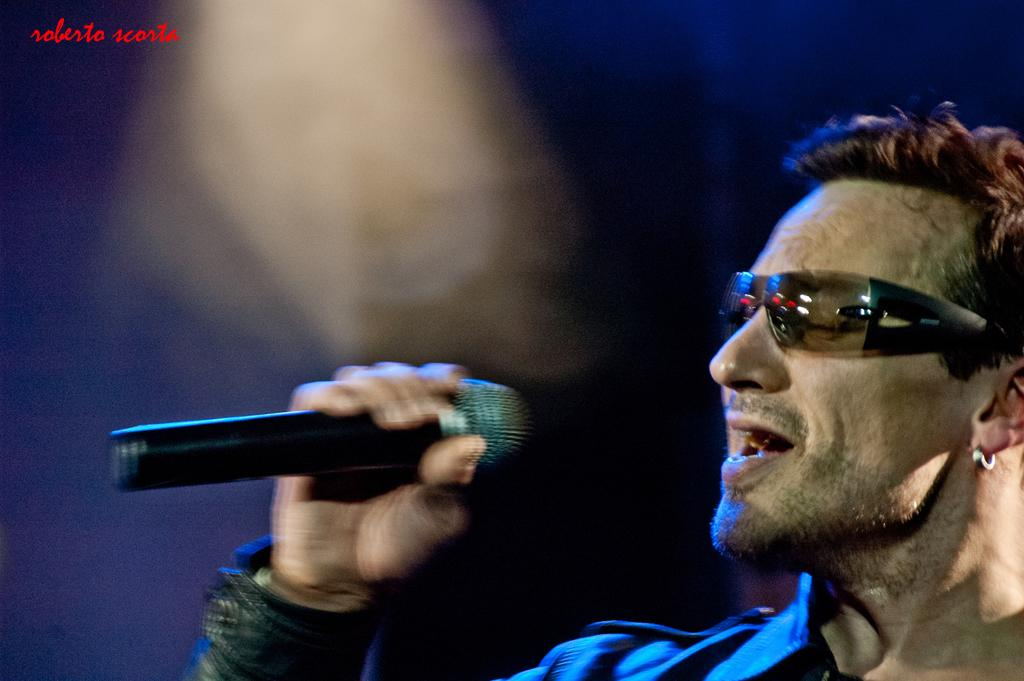What is the main subject of the image? There is a person in the image. What is the person wearing? The person is wearing a blue shirt. What is the person holding? The person is holding a microphone. What is the person doing in the image? The person is singing. What can be seen in the top left corner of the image? There is a watermark in the top left corner of the image. How would you describe the background of the image? The background of the image is blurred. What type of snake can be seen crawling on the person's shoulder in the image? There is no snake present in the image. How many days are in the week depicted in the image? There is no reference to a week or any days in the image. 